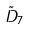<formula> <loc_0><loc_0><loc_500><loc_500>\tilde { D } _ { 7 }</formula> 